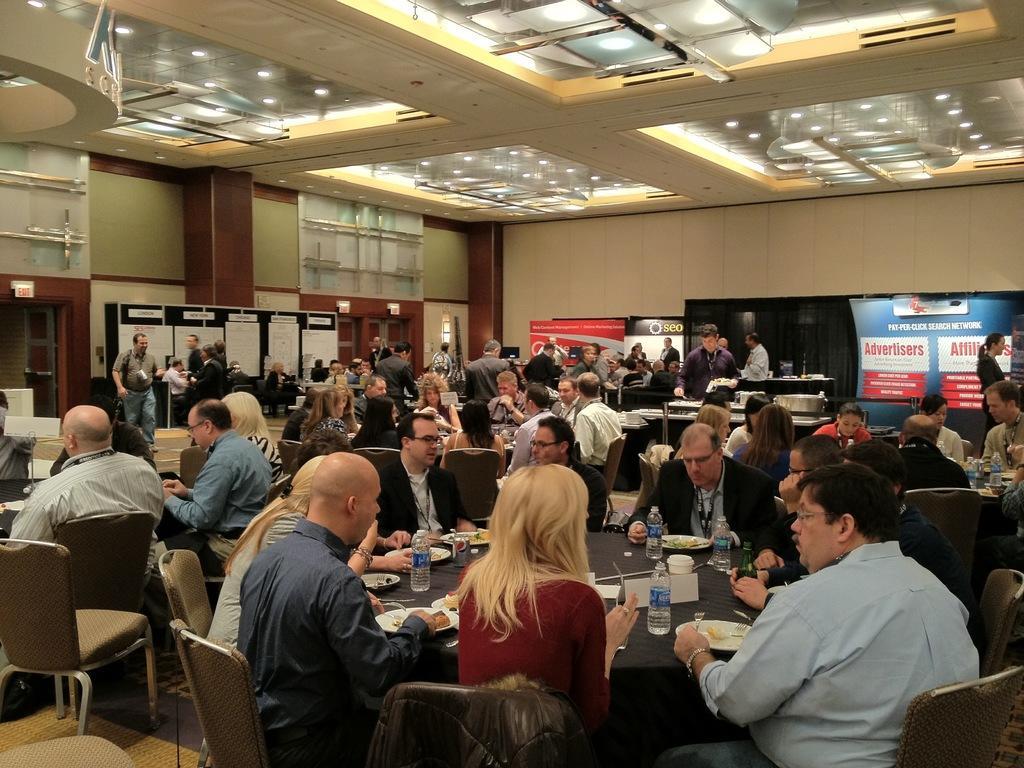In one or two sentences, can you explain what this image depicts? In this image, there is an inside view of a building. There are some persons wearing clothes and sitting in front of the table. This table is covered with a cloth and contains bottles and plates. There are some other persons sitting on chairs. There are some persons in the center of the image standing and wearing clothes. There are some banners on the right side of the image. There are lights at the top. 